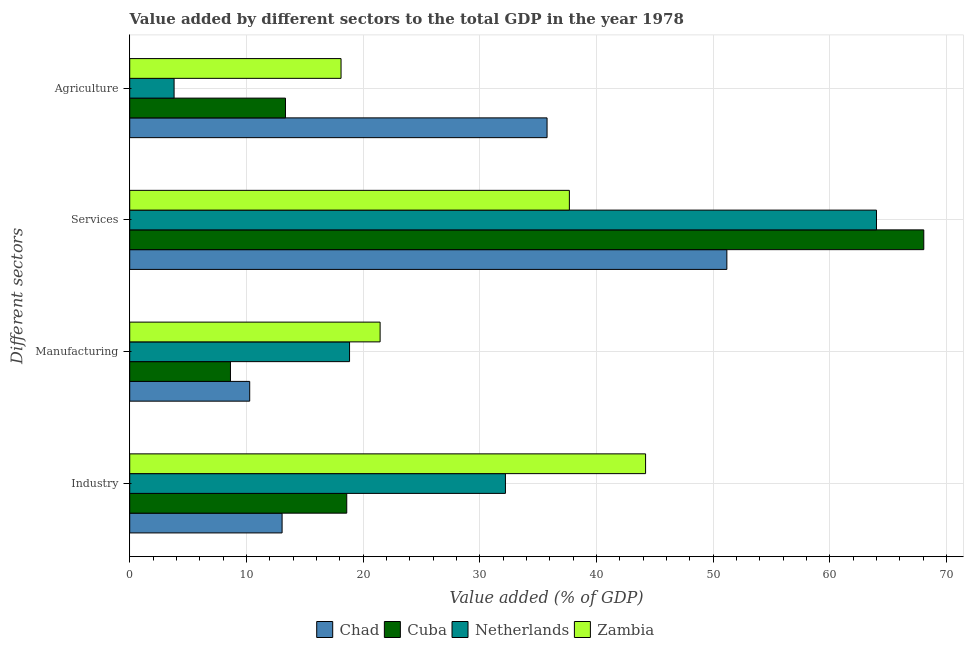How many different coloured bars are there?
Offer a terse response. 4. How many groups of bars are there?
Provide a succinct answer. 4. Are the number of bars on each tick of the Y-axis equal?
Offer a very short reply. Yes. How many bars are there on the 4th tick from the top?
Your answer should be very brief. 4. What is the label of the 1st group of bars from the top?
Keep it short and to the point. Agriculture. What is the value added by agricultural sector in Zambia?
Provide a succinct answer. 18.11. Across all countries, what is the maximum value added by services sector?
Offer a very short reply. 68.05. Across all countries, what is the minimum value added by industrial sector?
Ensure brevity in your answer.  13.06. In which country was the value added by agricultural sector maximum?
Give a very brief answer. Chad. What is the total value added by manufacturing sector in the graph?
Give a very brief answer. 59.21. What is the difference between the value added by services sector in Netherlands and that in Zambia?
Make the answer very short. 26.32. What is the difference between the value added by agricultural sector in Zambia and the value added by manufacturing sector in Netherlands?
Provide a succinct answer. -0.73. What is the average value added by services sector per country?
Your response must be concise. 55.23. What is the difference between the value added by services sector and value added by manufacturing sector in Netherlands?
Offer a terse response. 45.16. What is the ratio of the value added by industrial sector in Netherlands to that in Cuba?
Keep it short and to the point. 1.73. Is the value added by industrial sector in Chad less than that in Netherlands?
Your answer should be very brief. Yes. What is the difference between the highest and the second highest value added by industrial sector?
Offer a very short reply. 12.01. What is the difference between the highest and the lowest value added by industrial sector?
Your answer should be compact. 31.15. In how many countries, is the value added by manufacturing sector greater than the average value added by manufacturing sector taken over all countries?
Give a very brief answer. 2. Is the sum of the value added by industrial sector in Zambia and Cuba greater than the maximum value added by services sector across all countries?
Your answer should be very brief. No. Is it the case that in every country, the sum of the value added by manufacturing sector and value added by industrial sector is greater than the sum of value added by services sector and value added by agricultural sector?
Ensure brevity in your answer.  No. What does the 3rd bar from the top in Manufacturing represents?
Your response must be concise. Cuba. Is it the case that in every country, the sum of the value added by industrial sector and value added by manufacturing sector is greater than the value added by services sector?
Provide a succinct answer. No. How many bars are there?
Keep it short and to the point. 16. Are all the bars in the graph horizontal?
Offer a terse response. Yes. How many countries are there in the graph?
Provide a succinct answer. 4. Are the values on the major ticks of X-axis written in scientific E-notation?
Provide a succinct answer. No. Does the graph contain grids?
Ensure brevity in your answer.  Yes. How many legend labels are there?
Offer a terse response. 4. How are the legend labels stacked?
Provide a short and direct response. Horizontal. What is the title of the graph?
Give a very brief answer. Value added by different sectors to the total GDP in the year 1978. What is the label or title of the X-axis?
Offer a terse response. Value added (% of GDP). What is the label or title of the Y-axis?
Make the answer very short. Different sectors. What is the Value added (% of GDP) of Chad in Industry?
Give a very brief answer. 13.06. What is the Value added (% of GDP) in Cuba in Industry?
Offer a terse response. 18.6. What is the Value added (% of GDP) in Netherlands in Industry?
Make the answer very short. 32.2. What is the Value added (% of GDP) of Zambia in Industry?
Give a very brief answer. 44.21. What is the Value added (% of GDP) in Chad in Manufacturing?
Provide a short and direct response. 10.28. What is the Value added (% of GDP) in Cuba in Manufacturing?
Offer a terse response. 8.63. What is the Value added (% of GDP) in Netherlands in Manufacturing?
Your answer should be very brief. 18.84. What is the Value added (% of GDP) in Zambia in Manufacturing?
Your response must be concise. 21.46. What is the Value added (% of GDP) of Chad in Services?
Provide a succinct answer. 51.18. What is the Value added (% of GDP) of Cuba in Services?
Provide a succinct answer. 68.05. What is the Value added (% of GDP) of Netherlands in Services?
Provide a succinct answer. 64. What is the Value added (% of GDP) in Zambia in Services?
Your answer should be compact. 37.68. What is the Value added (% of GDP) in Chad in Agriculture?
Your answer should be very brief. 35.77. What is the Value added (% of GDP) in Cuba in Agriculture?
Offer a terse response. 13.35. What is the Value added (% of GDP) of Netherlands in Agriculture?
Give a very brief answer. 3.8. What is the Value added (% of GDP) of Zambia in Agriculture?
Make the answer very short. 18.11. Across all Different sectors, what is the maximum Value added (% of GDP) in Chad?
Your answer should be very brief. 51.18. Across all Different sectors, what is the maximum Value added (% of GDP) in Cuba?
Your response must be concise. 68.05. Across all Different sectors, what is the maximum Value added (% of GDP) of Netherlands?
Your response must be concise. 64. Across all Different sectors, what is the maximum Value added (% of GDP) of Zambia?
Your response must be concise. 44.21. Across all Different sectors, what is the minimum Value added (% of GDP) of Chad?
Offer a terse response. 10.28. Across all Different sectors, what is the minimum Value added (% of GDP) of Cuba?
Your answer should be compact. 8.63. Across all Different sectors, what is the minimum Value added (% of GDP) in Netherlands?
Keep it short and to the point. 3.8. Across all Different sectors, what is the minimum Value added (% of GDP) in Zambia?
Give a very brief answer. 18.11. What is the total Value added (% of GDP) in Chad in the graph?
Ensure brevity in your answer.  110.28. What is the total Value added (% of GDP) of Cuba in the graph?
Your answer should be compact. 108.63. What is the total Value added (% of GDP) of Netherlands in the graph?
Your response must be concise. 118.84. What is the total Value added (% of GDP) in Zambia in the graph?
Your answer should be compact. 121.46. What is the difference between the Value added (% of GDP) of Chad in Industry and that in Manufacturing?
Keep it short and to the point. 2.78. What is the difference between the Value added (% of GDP) of Cuba in Industry and that in Manufacturing?
Your answer should be compact. 9.97. What is the difference between the Value added (% of GDP) of Netherlands in Industry and that in Manufacturing?
Provide a short and direct response. 13.36. What is the difference between the Value added (% of GDP) of Zambia in Industry and that in Manufacturing?
Give a very brief answer. 22.75. What is the difference between the Value added (% of GDP) of Chad in Industry and that in Services?
Make the answer very short. -38.12. What is the difference between the Value added (% of GDP) in Cuba in Industry and that in Services?
Provide a short and direct response. -49.45. What is the difference between the Value added (% of GDP) of Netherlands in Industry and that in Services?
Your answer should be very brief. -31.8. What is the difference between the Value added (% of GDP) of Zambia in Industry and that in Services?
Your answer should be compact. 6.53. What is the difference between the Value added (% of GDP) in Chad in Industry and that in Agriculture?
Your answer should be compact. -22.71. What is the difference between the Value added (% of GDP) in Cuba in Industry and that in Agriculture?
Your answer should be very brief. 5.25. What is the difference between the Value added (% of GDP) in Netherlands in Industry and that in Agriculture?
Your answer should be very brief. 28.4. What is the difference between the Value added (% of GDP) of Zambia in Industry and that in Agriculture?
Offer a very short reply. 26.1. What is the difference between the Value added (% of GDP) of Chad in Manufacturing and that in Services?
Offer a terse response. -40.89. What is the difference between the Value added (% of GDP) in Cuba in Manufacturing and that in Services?
Keep it short and to the point. -59.42. What is the difference between the Value added (% of GDP) in Netherlands in Manufacturing and that in Services?
Make the answer very short. -45.16. What is the difference between the Value added (% of GDP) of Zambia in Manufacturing and that in Services?
Make the answer very short. -16.22. What is the difference between the Value added (% of GDP) of Chad in Manufacturing and that in Agriculture?
Your response must be concise. -25.48. What is the difference between the Value added (% of GDP) of Cuba in Manufacturing and that in Agriculture?
Offer a terse response. -4.72. What is the difference between the Value added (% of GDP) in Netherlands in Manufacturing and that in Agriculture?
Ensure brevity in your answer.  15.04. What is the difference between the Value added (% of GDP) in Zambia in Manufacturing and that in Agriculture?
Ensure brevity in your answer.  3.35. What is the difference between the Value added (% of GDP) in Chad in Services and that in Agriculture?
Offer a terse response. 15.41. What is the difference between the Value added (% of GDP) in Cuba in Services and that in Agriculture?
Keep it short and to the point. 54.7. What is the difference between the Value added (% of GDP) of Netherlands in Services and that in Agriculture?
Provide a short and direct response. 60.2. What is the difference between the Value added (% of GDP) in Zambia in Services and that in Agriculture?
Offer a very short reply. 19.57. What is the difference between the Value added (% of GDP) of Chad in Industry and the Value added (% of GDP) of Cuba in Manufacturing?
Your answer should be compact. 4.43. What is the difference between the Value added (% of GDP) in Chad in Industry and the Value added (% of GDP) in Netherlands in Manufacturing?
Keep it short and to the point. -5.78. What is the difference between the Value added (% of GDP) of Chad in Industry and the Value added (% of GDP) of Zambia in Manufacturing?
Make the answer very short. -8.4. What is the difference between the Value added (% of GDP) of Cuba in Industry and the Value added (% of GDP) of Netherlands in Manufacturing?
Provide a succinct answer. -0.24. What is the difference between the Value added (% of GDP) in Cuba in Industry and the Value added (% of GDP) in Zambia in Manufacturing?
Provide a succinct answer. -2.86. What is the difference between the Value added (% of GDP) of Netherlands in Industry and the Value added (% of GDP) of Zambia in Manufacturing?
Keep it short and to the point. 10.74. What is the difference between the Value added (% of GDP) in Chad in Industry and the Value added (% of GDP) in Cuba in Services?
Ensure brevity in your answer.  -54.99. What is the difference between the Value added (% of GDP) in Chad in Industry and the Value added (% of GDP) in Netherlands in Services?
Give a very brief answer. -50.94. What is the difference between the Value added (% of GDP) in Chad in Industry and the Value added (% of GDP) in Zambia in Services?
Offer a terse response. -24.62. What is the difference between the Value added (% of GDP) of Cuba in Industry and the Value added (% of GDP) of Netherlands in Services?
Give a very brief answer. -45.4. What is the difference between the Value added (% of GDP) of Cuba in Industry and the Value added (% of GDP) of Zambia in Services?
Ensure brevity in your answer.  -19.08. What is the difference between the Value added (% of GDP) of Netherlands in Industry and the Value added (% of GDP) of Zambia in Services?
Keep it short and to the point. -5.48. What is the difference between the Value added (% of GDP) in Chad in Industry and the Value added (% of GDP) in Cuba in Agriculture?
Offer a terse response. -0.29. What is the difference between the Value added (% of GDP) of Chad in Industry and the Value added (% of GDP) of Netherlands in Agriculture?
Make the answer very short. 9.26. What is the difference between the Value added (% of GDP) of Chad in Industry and the Value added (% of GDP) of Zambia in Agriculture?
Provide a succinct answer. -5.05. What is the difference between the Value added (% of GDP) of Cuba in Industry and the Value added (% of GDP) of Netherlands in Agriculture?
Give a very brief answer. 14.8. What is the difference between the Value added (% of GDP) in Cuba in Industry and the Value added (% of GDP) in Zambia in Agriculture?
Make the answer very short. 0.49. What is the difference between the Value added (% of GDP) in Netherlands in Industry and the Value added (% of GDP) in Zambia in Agriculture?
Make the answer very short. 14.09. What is the difference between the Value added (% of GDP) in Chad in Manufacturing and the Value added (% of GDP) in Cuba in Services?
Offer a very short reply. -57.77. What is the difference between the Value added (% of GDP) of Chad in Manufacturing and the Value added (% of GDP) of Netherlands in Services?
Give a very brief answer. -53.72. What is the difference between the Value added (% of GDP) of Chad in Manufacturing and the Value added (% of GDP) of Zambia in Services?
Offer a very short reply. -27.4. What is the difference between the Value added (% of GDP) of Cuba in Manufacturing and the Value added (% of GDP) of Netherlands in Services?
Your response must be concise. -55.37. What is the difference between the Value added (% of GDP) in Cuba in Manufacturing and the Value added (% of GDP) in Zambia in Services?
Your response must be concise. -29.05. What is the difference between the Value added (% of GDP) in Netherlands in Manufacturing and the Value added (% of GDP) in Zambia in Services?
Make the answer very short. -18.84. What is the difference between the Value added (% of GDP) of Chad in Manufacturing and the Value added (% of GDP) of Cuba in Agriculture?
Offer a very short reply. -3.07. What is the difference between the Value added (% of GDP) of Chad in Manufacturing and the Value added (% of GDP) of Netherlands in Agriculture?
Provide a succinct answer. 6.48. What is the difference between the Value added (% of GDP) in Chad in Manufacturing and the Value added (% of GDP) in Zambia in Agriculture?
Provide a short and direct response. -7.83. What is the difference between the Value added (% of GDP) of Cuba in Manufacturing and the Value added (% of GDP) of Netherlands in Agriculture?
Offer a terse response. 4.83. What is the difference between the Value added (% of GDP) in Cuba in Manufacturing and the Value added (% of GDP) in Zambia in Agriculture?
Your answer should be very brief. -9.48. What is the difference between the Value added (% of GDP) in Netherlands in Manufacturing and the Value added (% of GDP) in Zambia in Agriculture?
Your answer should be very brief. 0.73. What is the difference between the Value added (% of GDP) of Chad in Services and the Value added (% of GDP) of Cuba in Agriculture?
Give a very brief answer. 37.83. What is the difference between the Value added (% of GDP) in Chad in Services and the Value added (% of GDP) in Netherlands in Agriculture?
Your answer should be compact. 47.37. What is the difference between the Value added (% of GDP) in Chad in Services and the Value added (% of GDP) in Zambia in Agriculture?
Offer a very short reply. 33.06. What is the difference between the Value added (% of GDP) in Cuba in Services and the Value added (% of GDP) in Netherlands in Agriculture?
Offer a terse response. 64.25. What is the difference between the Value added (% of GDP) in Cuba in Services and the Value added (% of GDP) in Zambia in Agriculture?
Your answer should be very brief. 49.94. What is the difference between the Value added (% of GDP) in Netherlands in Services and the Value added (% of GDP) in Zambia in Agriculture?
Provide a short and direct response. 45.89. What is the average Value added (% of GDP) in Chad per Different sectors?
Keep it short and to the point. 27.57. What is the average Value added (% of GDP) in Cuba per Different sectors?
Make the answer very short. 27.16. What is the average Value added (% of GDP) in Netherlands per Different sectors?
Ensure brevity in your answer.  29.71. What is the average Value added (% of GDP) in Zambia per Different sectors?
Offer a very short reply. 30.36. What is the difference between the Value added (% of GDP) of Chad and Value added (% of GDP) of Cuba in Industry?
Give a very brief answer. -5.54. What is the difference between the Value added (% of GDP) of Chad and Value added (% of GDP) of Netherlands in Industry?
Ensure brevity in your answer.  -19.14. What is the difference between the Value added (% of GDP) of Chad and Value added (% of GDP) of Zambia in Industry?
Your answer should be very brief. -31.15. What is the difference between the Value added (% of GDP) in Cuba and Value added (% of GDP) in Netherlands in Industry?
Offer a very short reply. -13.6. What is the difference between the Value added (% of GDP) of Cuba and Value added (% of GDP) of Zambia in Industry?
Provide a short and direct response. -25.61. What is the difference between the Value added (% of GDP) in Netherlands and Value added (% of GDP) in Zambia in Industry?
Keep it short and to the point. -12.01. What is the difference between the Value added (% of GDP) of Chad and Value added (% of GDP) of Cuba in Manufacturing?
Your answer should be very brief. 1.65. What is the difference between the Value added (% of GDP) of Chad and Value added (% of GDP) of Netherlands in Manufacturing?
Your answer should be very brief. -8.56. What is the difference between the Value added (% of GDP) in Chad and Value added (% of GDP) in Zambia in Manufacturing?
Your response must be concise. -11.18. What is the difference between the Value added (% of GDP) of Cuba and Value added (% of GDP) of Netherlands in Manufacturing?
Keep it short and to the point. -10.21. What is the difference between the Value added (% of GDP) in Cuba and Value added (% of GDP) in Zambia in Manufacturing?
Your answer should be very brief. -12.83. What is the difference between the Value added (% of GDP) of Netherlands and Value added (% of GDP) of Zambia in Manufacturing?
Keep it short and to the point. -2.62. What is the difference between the Value added (% of GDP) in Chad and Value added (% of GDP) in Cuba in Services?
Offer a terse response. -16.88. What is the difference between the Value added (% of GDP) of Chad and Value added (% of GDP) of Netherlands in Services?
Keep it short and to the point. -12.82. What is the difference between the Value added (% of GDP) of Chad and Value added (% of GDP) of Zambia in Services?
Provide a succinct answer. 13.5. What is the difference between the Value added (% of GDP) of Cuba and Value added (% of GDP) of Netherlands in Services?
Your answer should be compact. 4.05. What is the difference between the Value added (% of GDP) of Cuba and Value added (% of GDP) of Zambia in Services?
Keep it short and to the point. 30.37. What is the difference between the Value added (% of GDP) in Netherlands and Value added (% of GDP) in Zambia in Services?
Your response must be concise. 26.32. What is the difference between the Value added (% of GDP) in Chad and Value added (% of GDP) in Cuba in Agriculture?
Offer a very short reply. 22.42. What is the difference between the Value added (% of GDP) of Chad and Value added (% of GDP) of Netherlands in Agriculture?
Your response must be concise. 31.96. What is the difference between the Value added (% of GDP) in Chad and Value added (% of GDP) in Zambia in Agriculture?
Make the answer very short. 17.66. What is the difference between the Value added (% of GDP) in Cuba and Value added (% of GDP) in Netherlands in Agriculture?
Your answer should be very brief. 9.55. What is the difference between the Value added (% of GDP) of Cuba and Value added (% of GDP) of Zambia in Agriculture?
Your answer should be compact. -4.76. What is the difference between the Value added (% of GDP) of Netherlands and Value added (% of GDP) of Zambia in Agriculture?
Keep it short and to the point. -14.31. What is the ratio of the Value added (% of GDP) of Chad in Industry to that in Manufacturing?
Provide a succinct answer. 1.27. What is the ratio of the Value added (% of GDP) of Cuba in Industry to that in Manufacturing?
Give a very brief answer. 2.15. What is the ratio of the Value added (% of GDP) in Netherlands in Industry to that in Manufacturing?
Provide a succinct answer. 1.71. What is the ratio of the Value added (% of GDP) of Zambia in Industry to that in Manufacturing?
Your response must be concise. 2.06. What is the ratio of the Value added (% of GDP) in Chad in Industry to that in Services?
Provide a short and direct response. 0.26. What is the ratio of the Value added (% of GDP) in Cuba in Industry to that in Services?
Ensure brevity in your answer.  0.27. What is the ratio of the Value added (% of GDP) in Netherlands in Industry to that in Services?
Offer a terse response. 0.5. What is the ratio of the Value added (% of GDP) in Zambia in Industry to that in Services?
Give a very brief answer. 1.17. What is the ratio of the Value added (% of GDP) in Chad in Industry to that in Agriculture?
Keep it short and to the point. 0.37. What is the ratio of the Value added (% of GDP) in Cuba in Industry to that in Agriculture?
Provide a short and direct response. 1.39. What is the ratio of the Value added (% of GDP) of Netherlands in Industry to that in Agriculture?
Offer a very short reply. 8.47. What is the ratio of the Value added (% of GDP) of Zambia in Industry to that in Agriculture?
Provide a short and direct response. 2.44. What is the ratio of the Value added (% of GDP) in Chad in Manufacturing to that in Services?
Your answer should be very brief. 0.2. What is the ratio of the Value added (% of GDP) in Cuba in Manufacturing to that in Services?
Keep it short and to the point. 0.13. What is the ratio of the Value added (% of GDP) in Netherlands in Manufacturing to that in Services?
Make the answer very short. 0.29. What is the ratio of the Value added (% of GDP) in Zambia in Manufacturing to that in Services?
Your response must be concise. 0.57. What is the ratio of the Value added (% of GDP) of Chad in Manufacturing to that in Agriculture?
Your answer should be compact. 0.29. What is the ratio of the Value added (% of GDP) in Cuba in Manufacturing to that in Agriculture?
Provide a succinct answer. 0.65. What is the ratio of the Value added (% of GDP) in Netherlands in Manufacturing to that in Agriculture?
Offer a very short reply. 4.96. What is the ratio of the Value added (% of GDP) in Zambia in Manufacturing to that in Agriculture?
Keep it short and to the point. 1.18. What is the ratio of the Value added (% of GDP) of Chad in Services to that in Agriculture?
Offer a terse response. 1.43. What is the ratio of the Value added (% of GDP) in Cuba in Services to that in Agriculture?
Your answer should be very brief. 5.1. What is the ratio of the Value added (% of GDP) in Netherlands in Services to that in Agriculture?
Provide a succinct answer. 16.83. What is the ratio of the Value added (% of GDP) of Zambia in Services to that in Agriculture?
Offer a very short reply. 2.08. What is the difference between the highest and the second highest Value added (% of GDP) in Chad?
Your answer should be very brief. 15.41. What is the difference between the highest and the second highest Value added (% of GDP) of Cuba?
Your response must be concise. 49.45. What is the difference between the highest and the second highest Value added (% of GDP) in Netherlands?
Offer a very short reply. 31.8. What is the difference between the highest and the second highest Value added (% of GDP) in Zambia?
Your answer should be very brief. 6.53. What is the difference between the highest and the lowest Value added (% of GDP) of Chad?
Your answer should be compact. 40.89. What is the difference between the highest and the lowest Value added (% of GDP) of Cuba?
Provide a succinct answer. 59.42. What is the difference between the highest and the lowest Value added (% of GDP) of Netherlands?
Offer a terse response. 60.2. What is the difference between the highest and the lowest Value added (% of GDP) in Zambia?
Your answer should be compact. 26.1. 